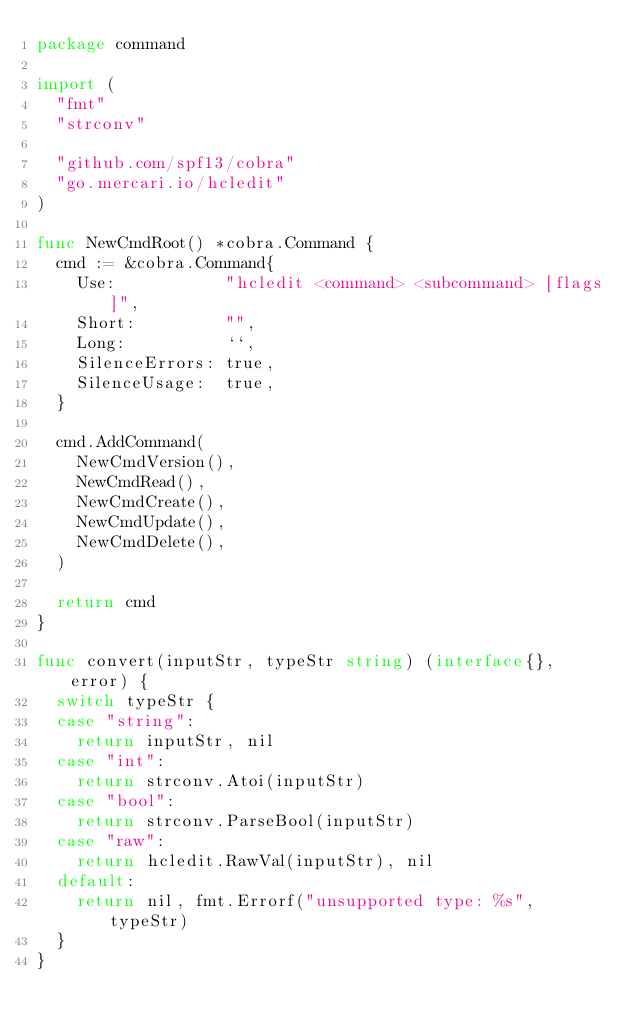<code> <loc_0><loc_0><loc_500><loc_500><_Go_>package command

import (
	"fmt"
	"strconv"

	"github.com/spf13/cobra"
	"go.mercari.io/hcledit"
)

func NewCmdRoot() *cobra.Command {
	cmd := &cobra.Command{
		Use:           "hcledit <command> <subcommand> [flags]",
		Short:         "",
		Long:          ``,
		SilenceErrors: true,
		SilenceUsage:  true,
	}

	cmd.AddCommand(
		NewCmdVersion(),
		NewCmdRead(),
		NewCmdCreate(),
		NewCmdUpdate(),
		NewCmdDelete(),
	)

	return cmd
}

func convert(inputStr, typeStr string) (interface{}, error) {
	switch typeStr {
	case "string":
		return inputStr, nil
	case "int":
		return strconv.Atoi(inputStr)
	case "bool":
		return strconv.ParseBool(inputStr)
	case "raw":
		return hcledit.RawVal(inputStr), nil
	default:
		return nil, fmt.Errorf("unsupported type: %s", typeStr)
	}
}
</code> 